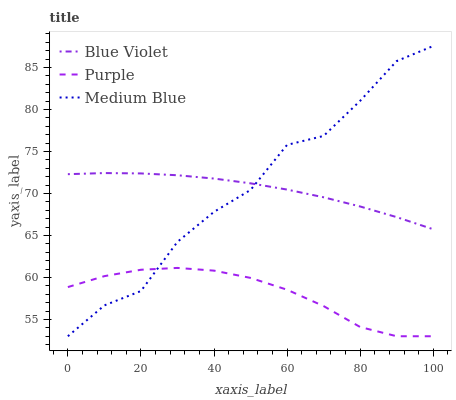Does Purple have the minimum area under the curve?
Answer yes or no. Yes. Does Medium Blue have the maximum area under the curve?
Answer yes or no. Yes. Does Blue Violet have the minimum area under the curve?
Answer yes or no. No. Does Blue Violet have the maximum area under the curve?
Answer yes or no. No. Is Blue Violet the smoothest?
Answer yes or no. Yes. Is Medium Blue the roughest?
Answer yes or no. Yes. Is Medium Blue the smoothest?
Answer yes or no. No. Is Blue Violet the roughest?
Answer yes or no. No. Does Purple have the lowest value?
Answer yes or no. Yes. Does Blue Violet have the lowest value?
Answer yes or no. No. Does Medium Blue have the highest value?
Answer yes or no. Yes. Does Blue Violet have the highest value?
Answer yes or no. No. Is Purple less than Blue Violet?
Answer yes or no. Yes. Is Blue Violet greater than Purple?
Answer yes or no. Yes. Does Blue Violet intersect Medium Blue?
Answer yes or no. Yes. Is Blue Violet less than Medium Blue?
Answer yes or no. No. Is Blue Violet greater than Medium Blue?
Answer yes or no. No. Does Purple intersect Blue Violet?
Answer yes or no. No. 